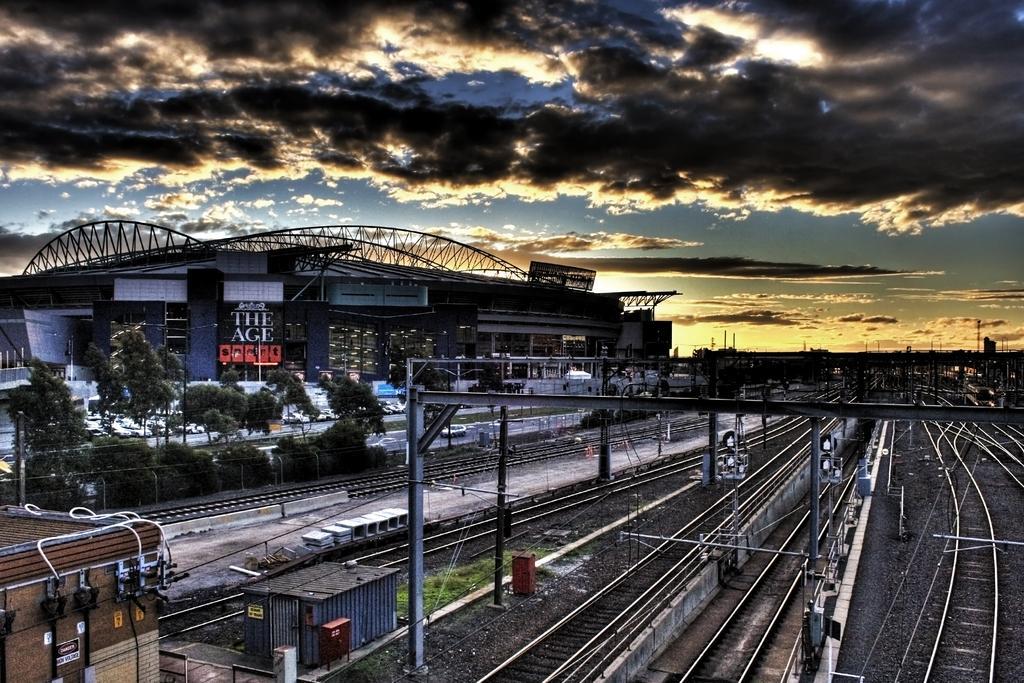Describe this image in one or two sentences. In this picture we can see many railway tracks. In the bottom left corner we can see the shed, beside that we can see some steel boxes and grass. On the left we can see the building, beside that we can see the roads. Beside the trees we can see many cars which parked in the parking. At the top we can see the sky and clouds. 